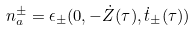<formula> <loc_0><loc_0><loc_500><loc_500>n _ { a } ^ { \pm } = \epsilon _ { \pm } ( { 0 } , - \dot { Z } ( \tau ) , \dot { t } _ { \pm } ( \tau ) )</formula> 